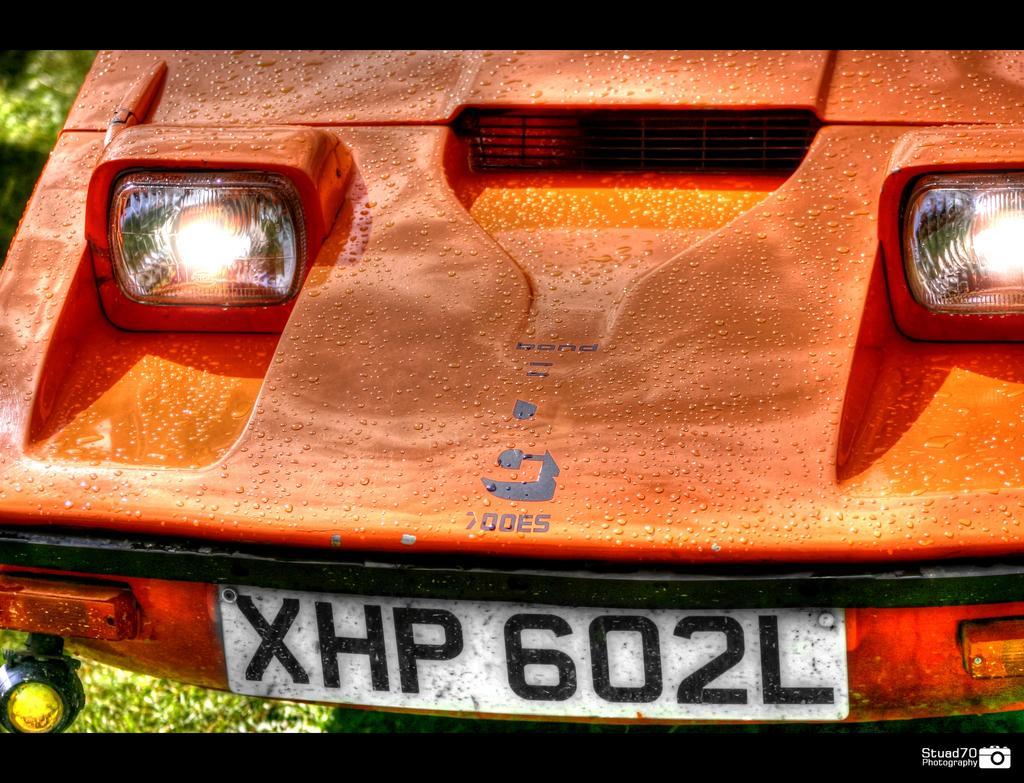What is the focus of the image? The image is zoomed in on the front part of a vehicle. What specific features of the vehicle can be seen in the image? The number plate and headlights of the vehicle are visible. What can be seen in the background of the image? There are plants in the background of the image. How many apples are being served by the servant in the image? There is no servant or apples present in the image. What type of nerve is visible in the image? There are no nerves visible in the image; it features a vehicle and plants in the background. 